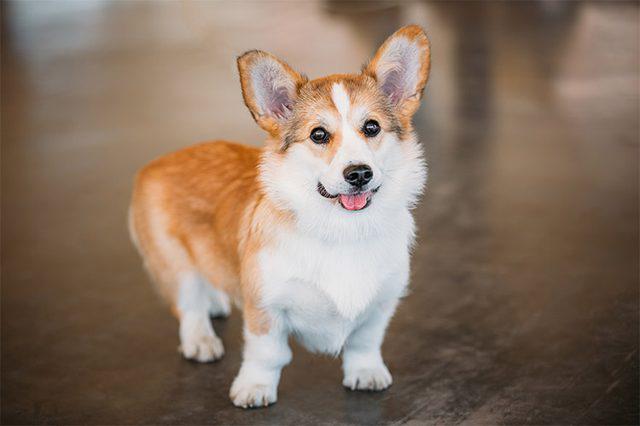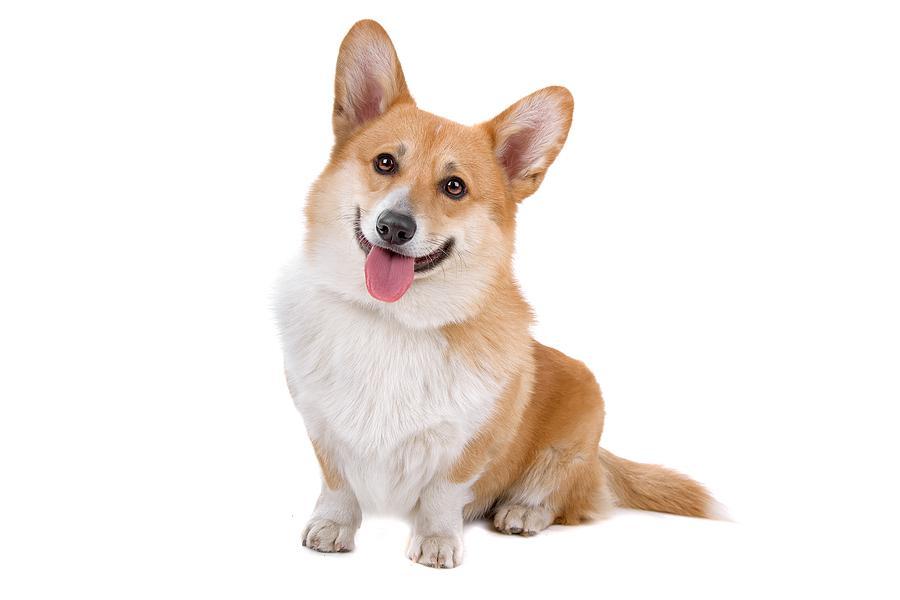The first image is the image on the left, the second image is the image on the right. For the images displayed, is the sentence "Two corgies with similar tan coloring and ears standing up have smiling expressions and tongues hanging out." factually correct? Answer yes or no. Yes. The first image is the image on the left, the second image is the image on the right. For the images displayed, is the sentence "The right image includes a tan and white dog that is sitting upright on a white background." factually correct? Answer yes or no. Yes. 